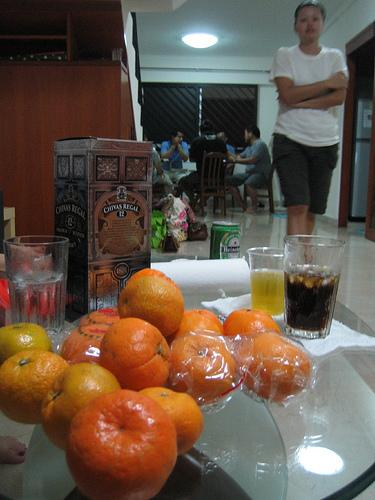The woman is doing what?

Choices:
A) crossing arms
B) running
C) stretching
D) jumping jacks crossing arms 